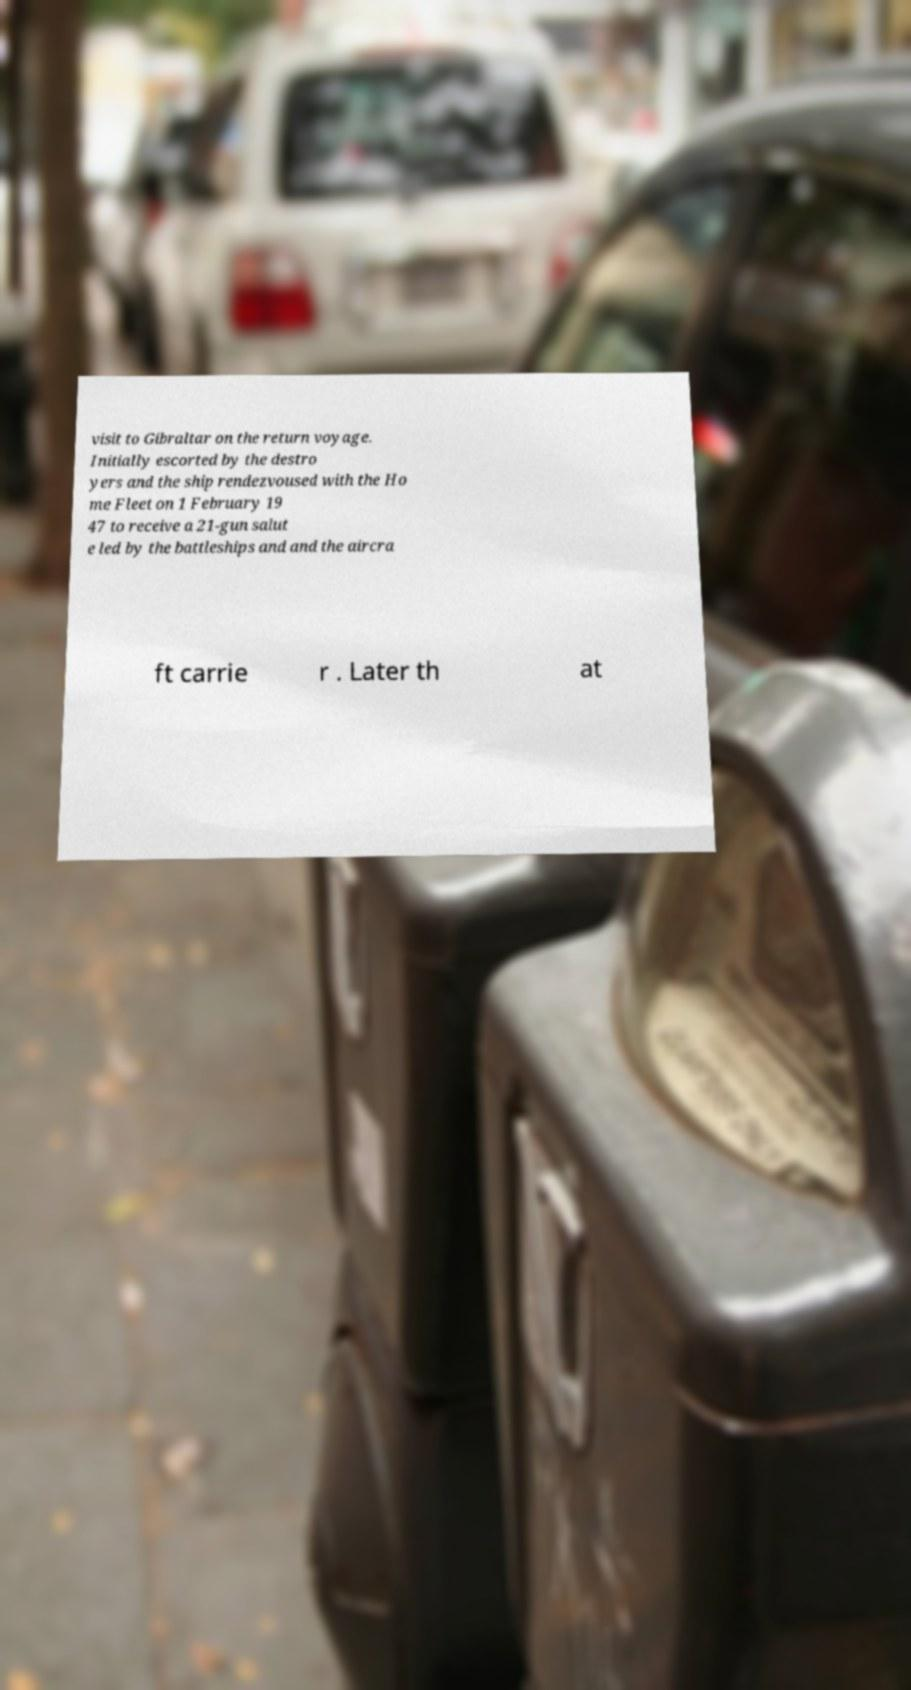I need the written content from this picture converted into text. Can you do that? visit to Gibraltar on the return voyage. Initially escorted by the destro yers and the ship rendezvoused with the Ho me Fleet on 1 February 19 47 to receive a 21-gun salut e led by the battleships and and the aircra ft carrie r . Later th at 